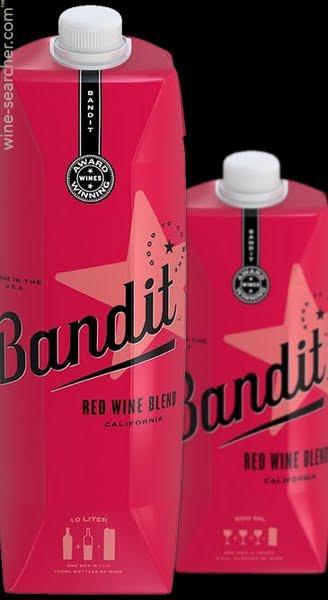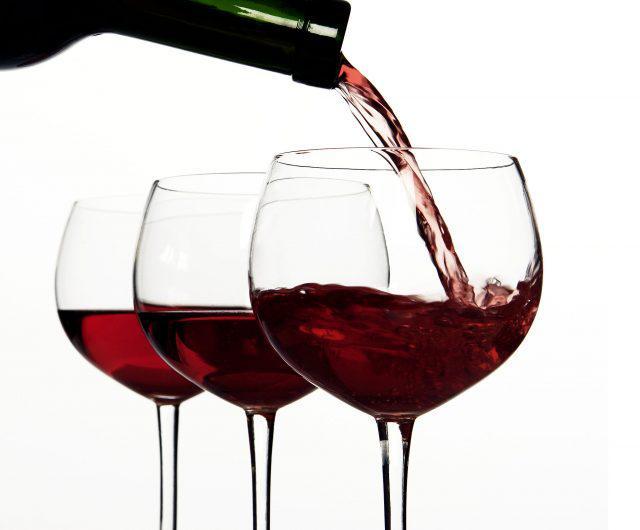The first image is the image on the left, the second image is the image on the right. Evaluate the accuracy of this statement regarding the images: "Three wine glasses are lined up in the image on the left.". Is it true? Answer yes or no. No. The first image is the image on the left, the second image is the image on the right. Examine the images to the left and right. Is the description "An image includes at least one bottle with a burgundy colored label and wrap over the cap." accurate? Answer yes or no. No. 